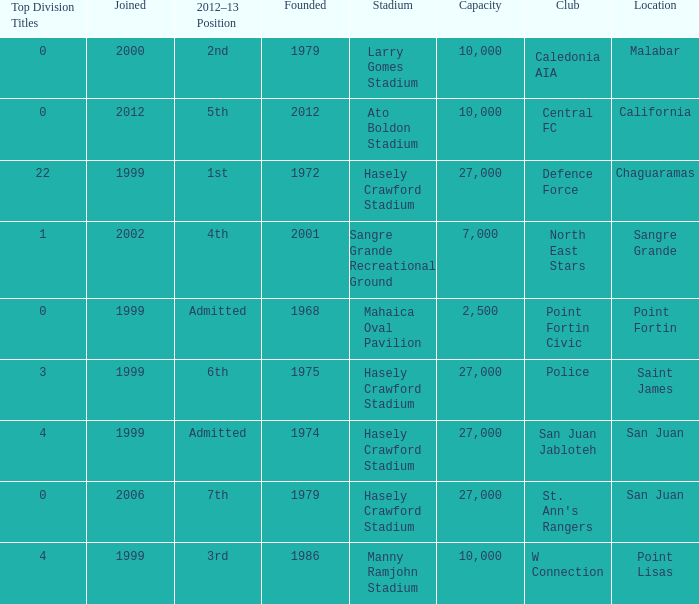What was the overall count of top division titles with a founding year before 1975 and situated in chaguaramas? 22.0. Help me parse the entirety of this table. {'header': ['Top Division Titles', 'Joined', '2012–13 Position', 'Founded', 'Stadium', 'Capacity', 'Club', 'Location'], 'rows': [['0', '2000', '2nd', '1979', 'Larry Gomes Stadium', '10,000', 'Caledonia AIA', 'Malabar'], ['0', '2012', '5th', '2012', 'Ato Boldon Stadium', '10,000', 'Central FC', 'California'], ['22', '1999', '1st', '1972', 'Hasely Crawford Stadium', '27,000', 'Defence Force', 'Chaguaramas'], ['1', '2002', '4th', '2001', 'Sangre Grande Recreational Ground', '7,000', 'North East Stars', 'Sangre Grande'], ['0', '1999', 'Admitted', '1968', 'Mahaica Oval Pavilion', '2,500', 'Point Fortin Civic', 'Point Fortin'], ['3', '1999', '6th', '1975', 'Hasely Crawford Stadium', '27,000', 'Police', 'Saint James'], ['4', '1999', 'Admitted', '1974', 'Hasely Crawford Stadium', '27,000', 'San Juan Jabloteh', 'San Juan'], ['0', '2006', '7th', '1979', 'Hasely Crawford Stadium', '27,000', "St. Ann's Rangers", 'San Juan'], ['4', '1999', '3rd', '1986', 'Manny Ramjohn Stadium', '10,000', 'W Connection', 'Point Lisas']]} 